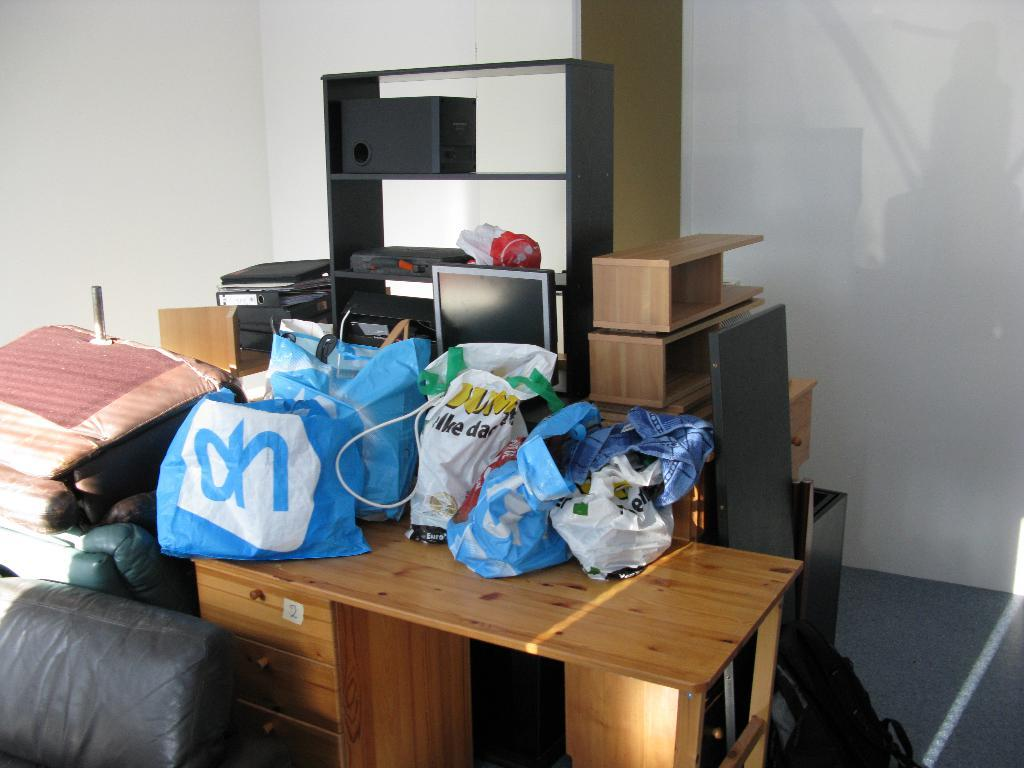<image>
Summarize the visual content of the image. The white and blue bag has Oh on the front 